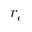<formula> <loc_0><loc_0><loc_500><loc_500>r _ { e }</formula> 